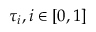Convert formula to latex. <formula><loc_0><loc_0><loc_500><loc_500>\tau _ { i } , i \in [ 0 , 1 ]</formula> 